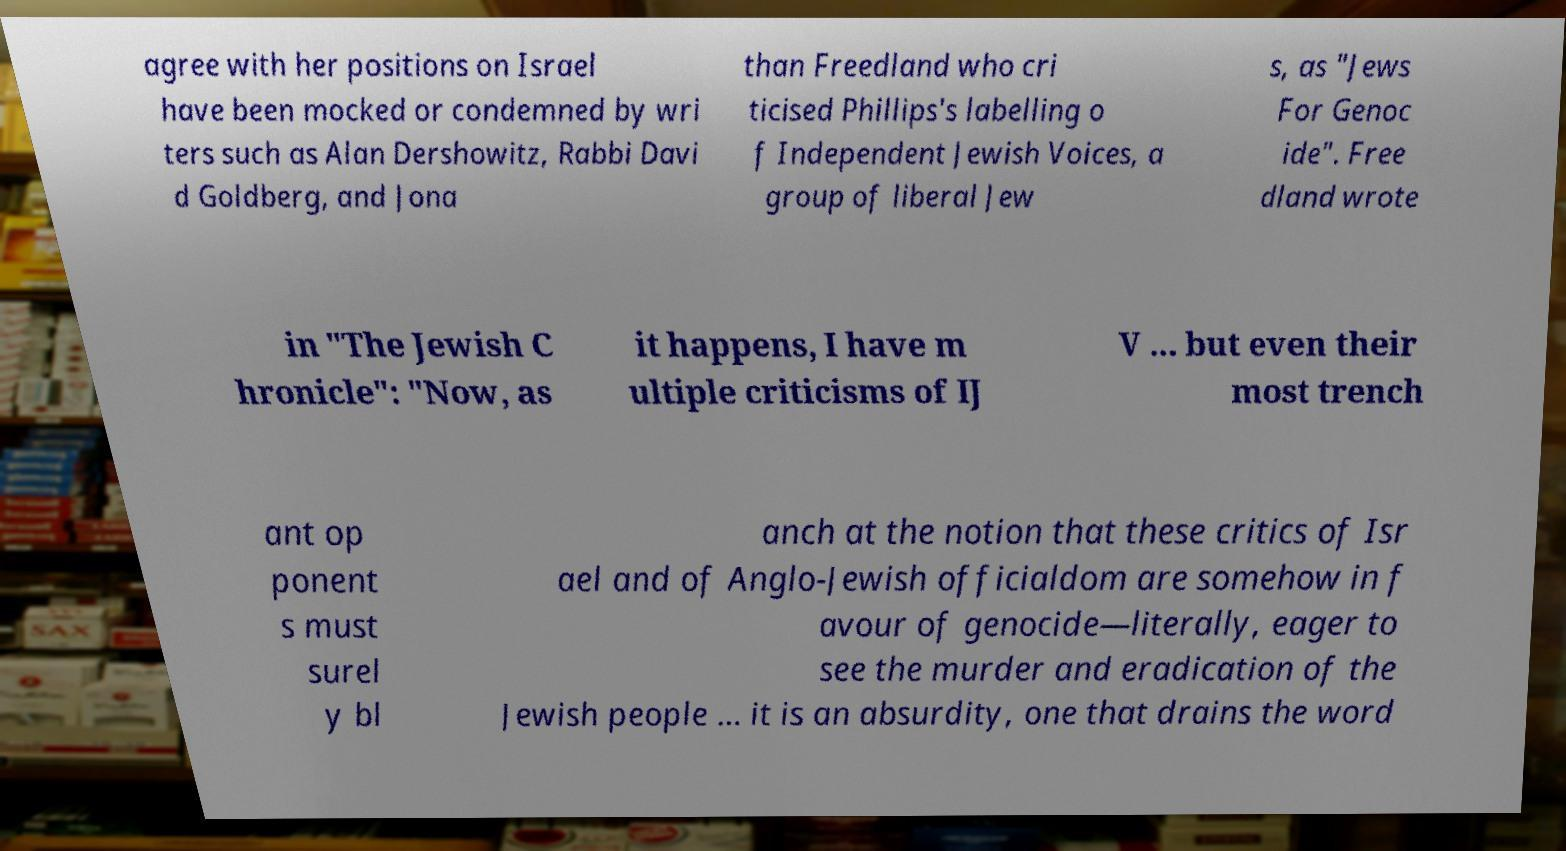What messages or text are displayed in this image? I need them in a readable, typed format. agree with her positions on Israel have been mocked or condemned by wri ters such as Alan Dershowitz, Rabbi Davi d Goldberg, and Jona than Freedland who cri ticised Phillips's labelling o f Independent Jewish Voices, a group of liberal Jew s, as "Jews For Genoc ide". Free dland wrote in "The Jewish C hronicle": "Now, as it happens, I have m ultiple criticisms of IJ V ... but even their most trench ant op ponent s must surel y bl anch at the notion that these critics of Isr ael and of Anglo-Jewish officialdom are somehow in f avour of genocide—literally, eager to see the murder and eradication of the Jewish people ... it is an absurdity, one that drains the word 